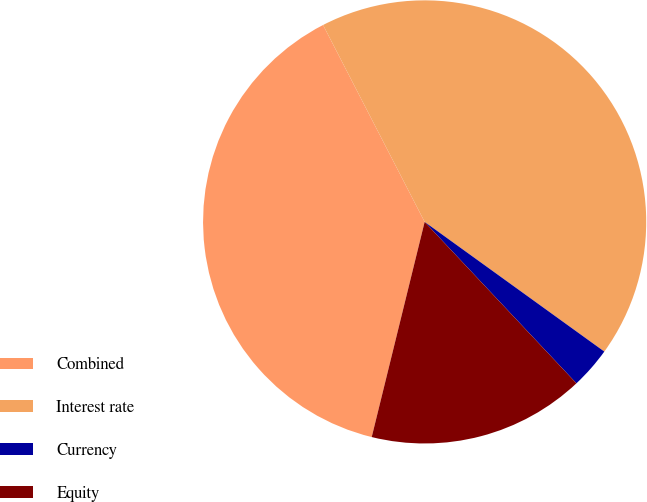Convert chart. <chart><loc_0><loc_0><loc_500><loc_500><pie_chart><fcel>Combined<fcel>Interest rate<fcel>Currency<fcel>Equity<nl><fcel>38.58%<fcel>42.53%<fcel>3.04%<fcel>15.85%<nl></chart> 